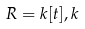<formula> <loc_0><loc_0><loc_500><loc_500>R = k [ t ] , k</formula> 